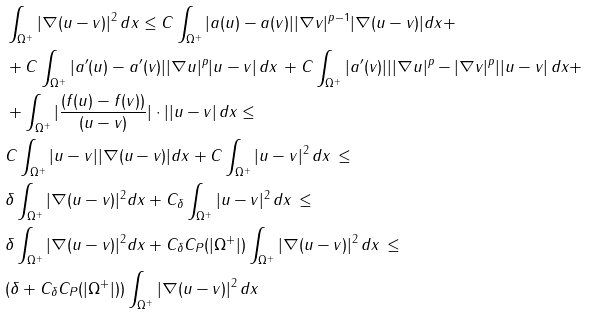<formula> <loc_0><loc_0><loc_500><loc_500>& \int _ { \Omega ^ { + } } | \nabla ( u - v ) | ^ { 2 } \, d x \leq C \int _ { \Omega ^ { + } } | a ( u ) - a ( v ) | | \nabla v | ^ { p - 1 } | \nabla ( u - v ) | d x + \\ & + C \int _ { \Omega ^ { + } } | a ^ { \prime } ( u ) - a ^ { \prime } ( v ) | | \nabla u | ^ { p } | u - v | \, d x \, + C \int _ { \Omega ^ { + } } | a ^ { \prime } ( v ) | | | \nabla u | ^ { p } - | \nabla v | ^ { p } | | u - v | \, d x + \\ & + \int _ { \Omega ^ { + } } | \frac { ( f ( u ) - f ( v ) ) } { ( u - v ) } | \cdot | | u - v | \, d x \leq \\ & C \int _ { \Omega ^ { + } } | u - v | | \nabla ( u - v ) | d x + C \int _ { \Omega ^ { + } } | u - v | ^ { 2 } \, d x \, \leq \\ & \delta \int _ { \Omega ^ { + } } | \nabla ( u - v ) | ^ { 2 } d x + C _ { \delta } \int _ { \Omega ^ { + } } | u - v | ^ { 2 } \, d x \, \leq \\ & \delta \int _ { \Omega ^ { + } } | \nabla ( u - v ) | ^ { 2 } d x + C _ { \delta } C _ { P } ( | \Omega ^ { + } | ) \int _ { \Omega ^ { + } } | \nabla ( u - v ) | ^ { 2 } \, d x \, \leq \\ & ( \delta + C _ { \delta } C _ { P } ( | \Omega ^ { + } | ) ) \int _ { \Omega ^ { + } } | \nabla ( u - v ) | ^ { 2 } \, d x</formula> 